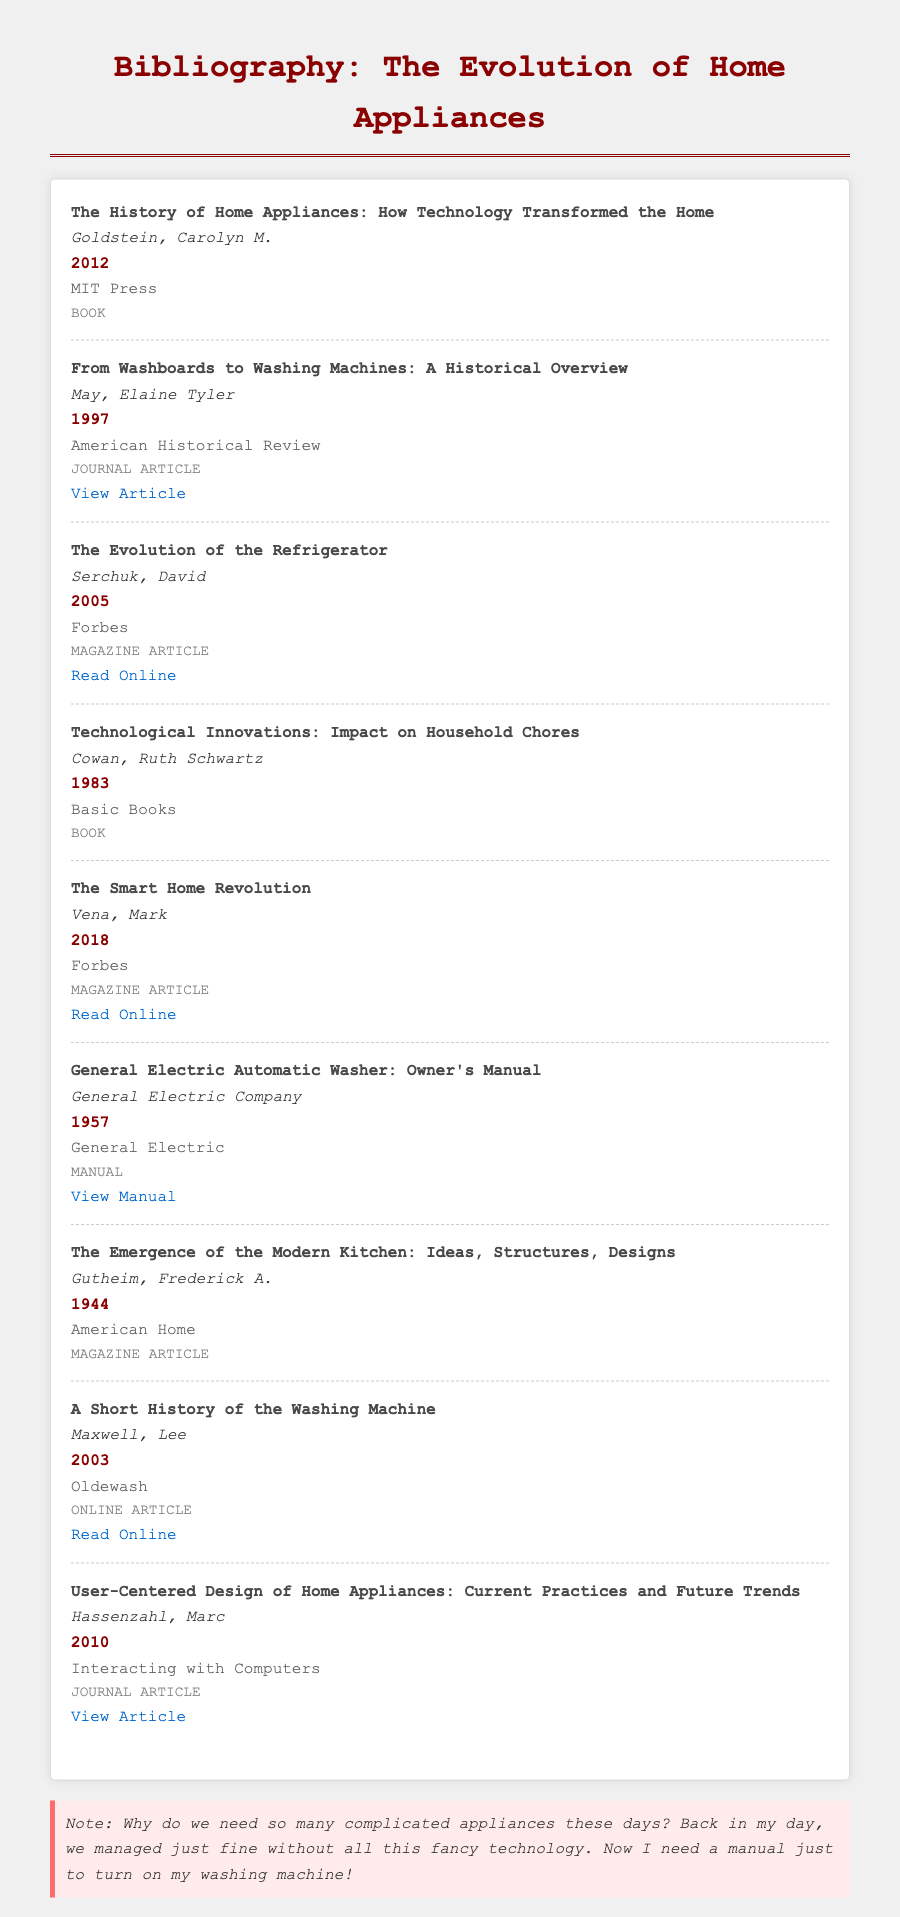what is the title of the first entry? The title of the first entry is given in the bibliography section, which is "The History of Home Appliances: How Technology Transformed the Home."
Answer: The History of Home Appliances: How Technology Transformed the Home who is the author of the article about washing machines? The entry about washing machines lists Elaine Tyler May as the author of the journal article titled "From Washboards to Washing Machines: A Historical Overview."
Answer: Elaine Tyler May what year was the refrigerator evolution article published? The document provides the year of publication for "The Evolution of the Refrigerator," which is 2005.
Answer: 2005 which publisher released the manual for the General Electric Automatic Washer? The manual's entry lists General Electric Company as the publisher for the General Electric Automatic Washer owner’s manual.
Answer: General Electric Company which type of document is "User-Centered Design of Home Appliances: Current Practices and Future Trends"? The entry specifies that this document is a journal article.
Answer: Journal Article who wrote "A Short History of the Washing Machine"? The bibliography indicates that Lee Maxwell is the author of "A Short History of the Washing Machine."
Answer: Lee Maxwell how many articles are linked in the document? The document includes four entries that have clickable links to additional content.
Answer: 4 what is the publication year of "The Smart Home Revolution"? The document indicates that "The Smart Home Revolution" was published in 2018.
Answer: 2018 what type of document is "Technological Innovations: Impact on Household Chores"? According to the entry, this document is categorized as a book.
Answer: Book 